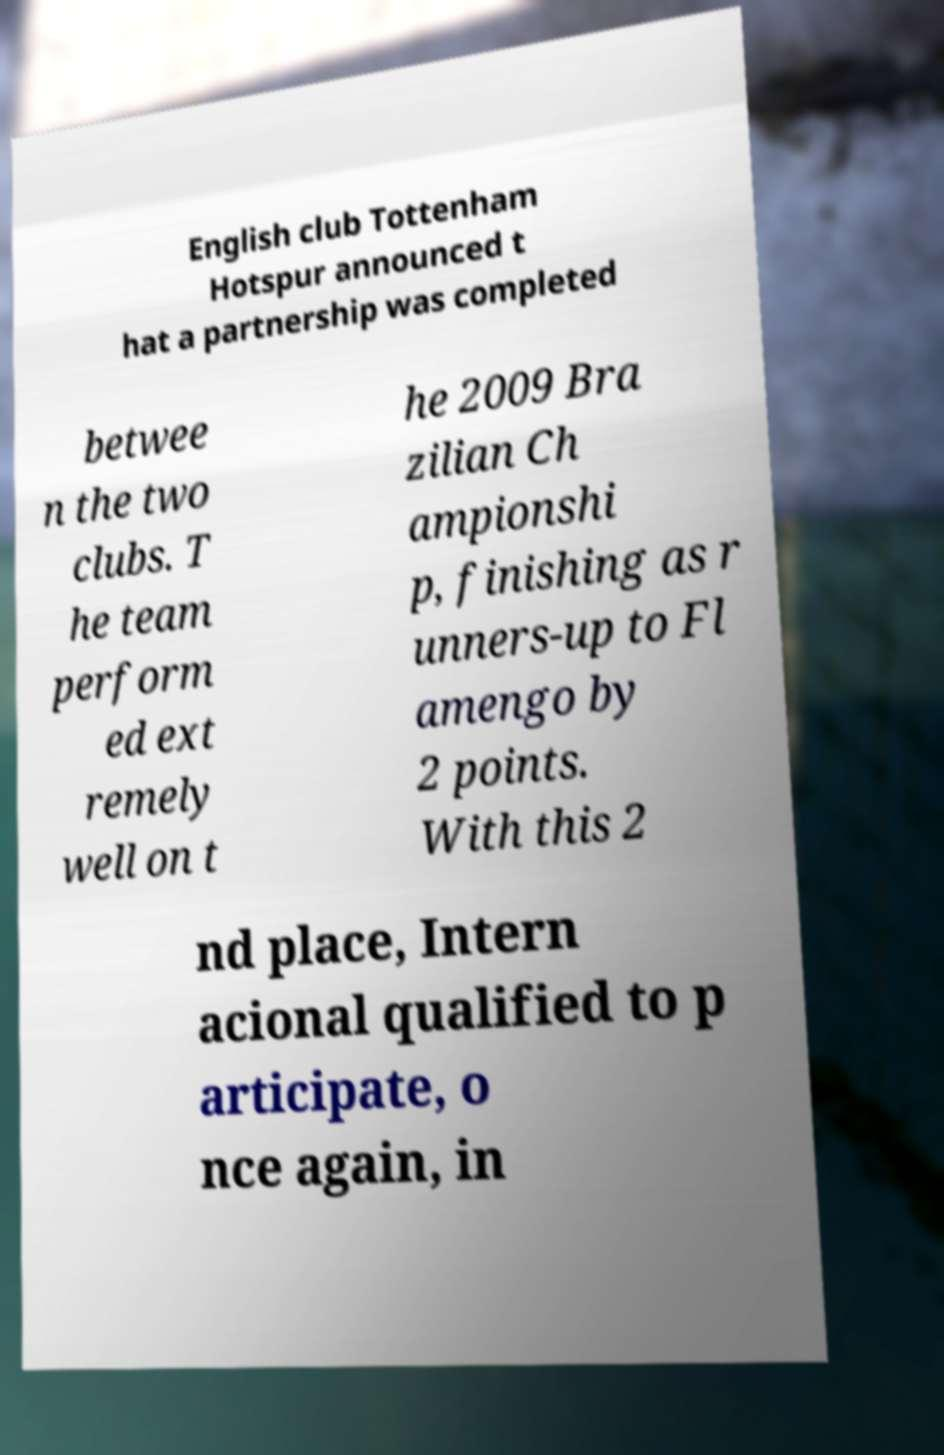For documentation purposes, I need the text within this image transcribed. Could you provide that? English club Tottenham Hotspur announced t hat a partnership was completed betwee n the two clubs. T he team perform ed ext remely well on t he 2009 Bra zilian Ch ampionshi p, finishing as r unners-up to Fl amengo by 2 points. With this 2 nd place, Intern acional qualified to p articipate, o nce again, in 